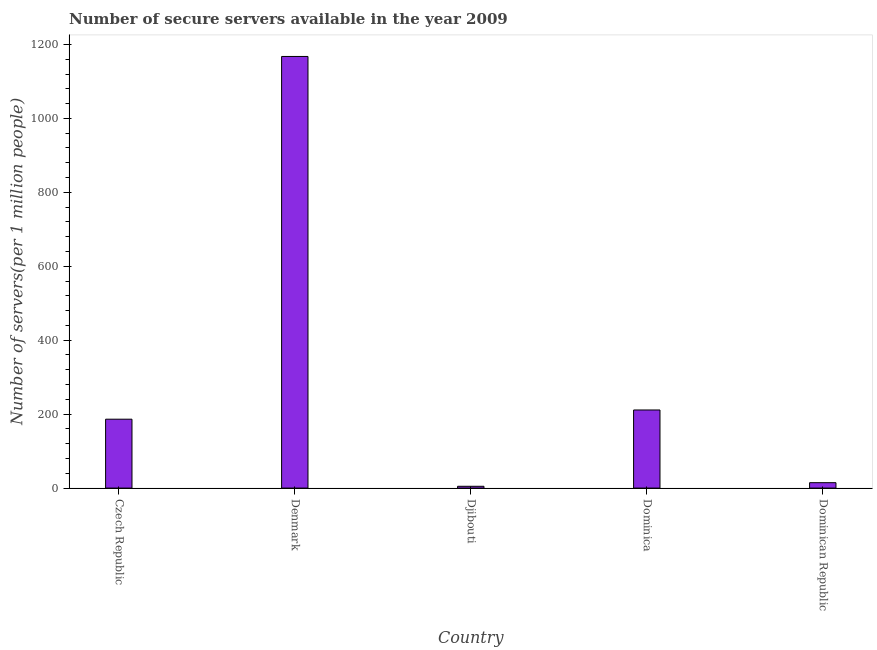Does the graph contain any zero values?
Your response must be concise. No. Does the graph contain grids?
Give a very brief answer. No. What is the title of the graph?
Provide a short and direct response. Number of secure servers available in the year 2009. What is the label or title of the X-axis?
Offer a terse response. Country. What is the label or title of the Y-axis?
Give a very brief answer. Number of servers(per 1 million people). What is the number of secure internet servers in Djibouti?
Provide a short and direct response. 4.88. Across all countries, what is the maximum number of secure internet servers?
Your response must be concise. 1167.46. Across all countries, what is the minimum number of secure internet servers?
Your answer should be compact. 4.88. In which country was the number of secure internet servers maximum?
Your answer should be very brief. Denmark. In which country was the number of secure internet servers minimum?
Your answer should be very brief. Djibouti. What is the sum of the number of secure internet servers?
Your answer should be very brief. 1584.59. What is the difference between the number of secure internet servers in Denmark and Dominican Republic?
Provide a short and direct response. 1152.82. What is the average number of secure internet servers per country?
Ensure brevity in your answer.  316.92. What is the median number of secure internet servers?
Your response must be concise. 186.33. In how many countries, is the number of secure internet servers greater than 880 ?
Your answer should be very brief. 1. What is the ratio of the number of secure internet servers in Djibouti to that in Dominican Republic?
Make the answer very short. 0.33. Is the number of secure internet servers in Djibouti less than that in Dominican Republic?
Your answer should be very brief. Yes. Is the difference between the number of secure internet servers in Dominica and Dominican Republic greater than the difference between any two countries?
Provide a short and direct response. No. What is the difference between the highest and the second highest number of secure internet servers?
Your response must be concise. 956.18. Is the sum of the number of secure internet servers in Djibouti and Dominican Republic greater than the maximum number of secure internet servers across all countries?
Your answer should be very brief. No. What is the difference between the highest and the lowest number of secure internet servers?
Your answer should be compact. 1162.58. In how many countries, is the number of secure internet servers greater than the average number of secure internet servers taken over all countries?
Keep it short and to the point. 1. How many bars are there?
Ensure brevity in your answer.  5. How many countries are there in the graph?
Your answer should be compact. 5. What is the difference between two consecutive major ticks on the Y-axis?
Offer a very short reply. 200. What is the Number of servers(per 1 million people) in Czech Republic?
Give a very brief answer. 186.33. What is the Number of servers(per 1 million people) of Denmark?
Offer a terse response. 1167.46. What is the Number of servers(per 1 million people) in Djibouti?
Your answer should be very brief. 4.88. What is the Number of servers(per 1 million people) in Dominica?
Offer a very short reply. 211.28. What is the Number of servers(per 1 million people) of Dominican Republic?
Give a very brief answer. 14.64. What is the difference between the Number of servers(per 1 million people) in Czech Republic and Denmark?
Offer a very short reply. -981.13. What is the difference between the Number of servers(per 1 million people) in Czech Republic and Djibouti?
Make the answer very short. 181.45. What is the difference between the Number of servers(per 1 million people) in Czech Republic and Dominica?
Provide a short and direct response. -24.95. What is the difference between the Number of servers(per 1 million people) in Czech Republic and Dominican Republic?
Offer a very short reply. 171.69. What is the difference between the Number of servers(per 1 million people) in Denmark and Djibouti?
Provide a short and direct response. 1162.58. What is the difference between the Number of servers(per 1 million people) in Denmark and Dominica?
Offer a very short reply. 956.18. What is the difference between the Number of servers(per 1 million people) in Denmark and Dominican Republic?
Your response must be concise. 1152.82. What is the difference between the Number of servers(per 1 million people) in Djibouti and Dominica?
Provide a short and direct response. -206.41. What is the difference between the Number of servers(per 1 million people) in Djibouti and Dominican Republic?
Offer a very short reply. -9.76. What is the difference between the Number of servers(per 1 million people) in Dominica and Dominican Republic?
Your answer should be compact. 196.64. What is the ratio of the Number of servers(per 1 million people) in Czech Republic to that in Denmark?
Your answer should be very brief. 0.16. What is the ratio of the Number of servers(per 1 million people) in Czech Republic to that in Djibouti?
Your answer should be compact. 38.2. What is the ratio of the Number of servers(per 1 million people) in Czech Republic to that in Dominica?
Keep it short and to the point. 0.88. What is the ratio of the Number of servers(per 1 million people) in Czech Republic to that in Dominican Republic?
Give a very brief answer. 12.73. What is the ratio of the Number of servers(per 1 million people) in Denmark to that in Djibouti?
Make the answer very short. 239.36. What is the ratio of the Number of servers(per 1 million people) in Denmark to that in Dominica?
Ensure brevity in your answer.  5.53. What is the ratio of the Number of servers(per 1 million people) in Denmark to that in Dominican Republic?
Keep it short and to the point. 79.74. What is the ratio of the Number of servers(per 1 million people) in Djibouti to that in Dominica?
Give a very brief answer. 0.02. What is the ratio of the Number of servers(per 1 million people) in Djibouti to that in Dominican Republic?
Offer a very short reply. 0.33. What is the ratio of the Number of servers(per 1 million people) in Dominica to that in Dominican Republic?
Offer a terse response. 14.43. 